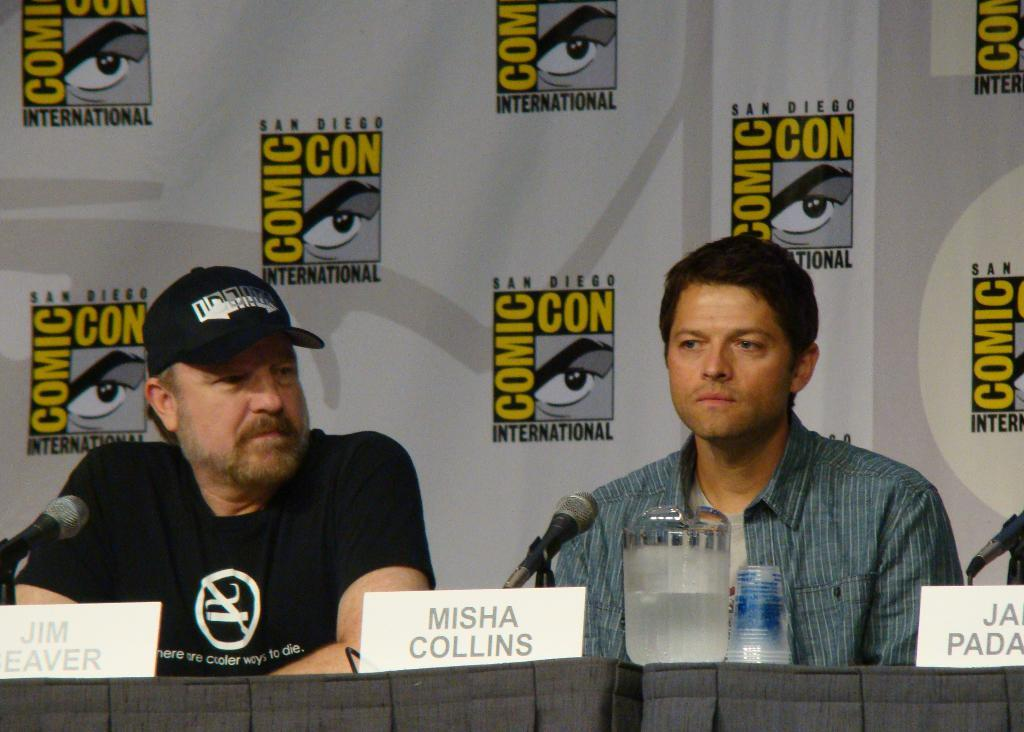<image>
Write a terse but informative summary of the picture. a couple men talking with one having a Misha Collins sign in front of them 